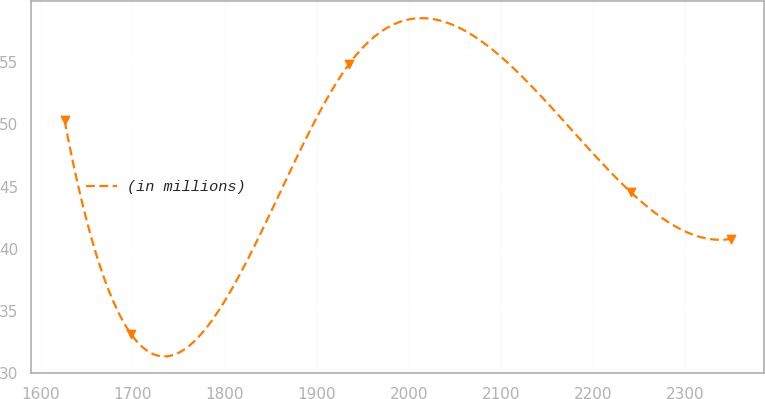<chart> <loc_0><loc_0><loc_500><loc_500><line_chart><ecel><fcel>(in millions)<nl><fcel>1626.26<fcel>50.31<nl><fcel>1698.53<fcel>33.14<nl><fcel>1935.19<fcel>54.86<nl><fcel>2240.78<fcel>44.54<nl><fcel>2348.91<fcel>40.79<nl></chart> 